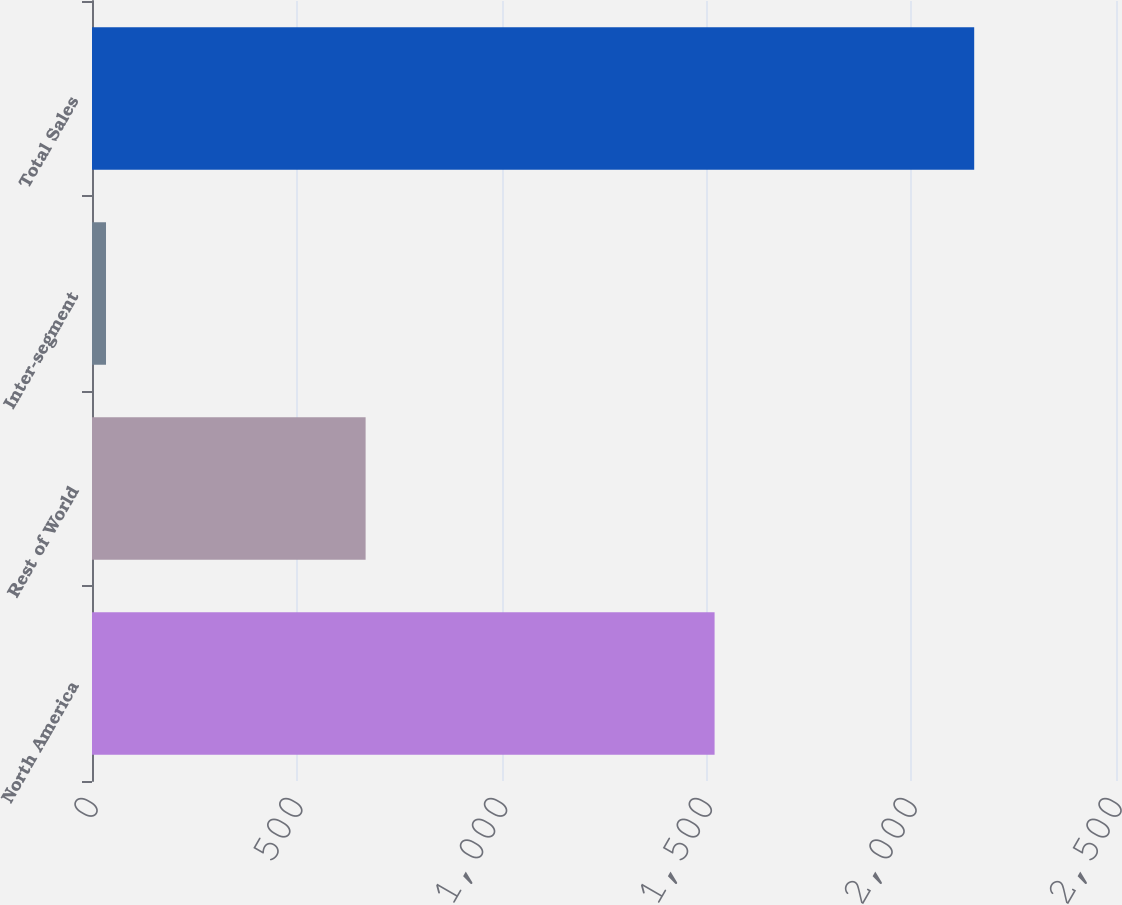Convert chart to OTSL. <chart><loc_0><loc_0><loc_500><loc_500><bar_chart><fcel>North America<fcel>Rest of World<fcel>Inter-segment<fcel>Total Sales<nl><fcel>1520<fcel>668<fcel>34.2<fcel>2153.8<nl></chart> 